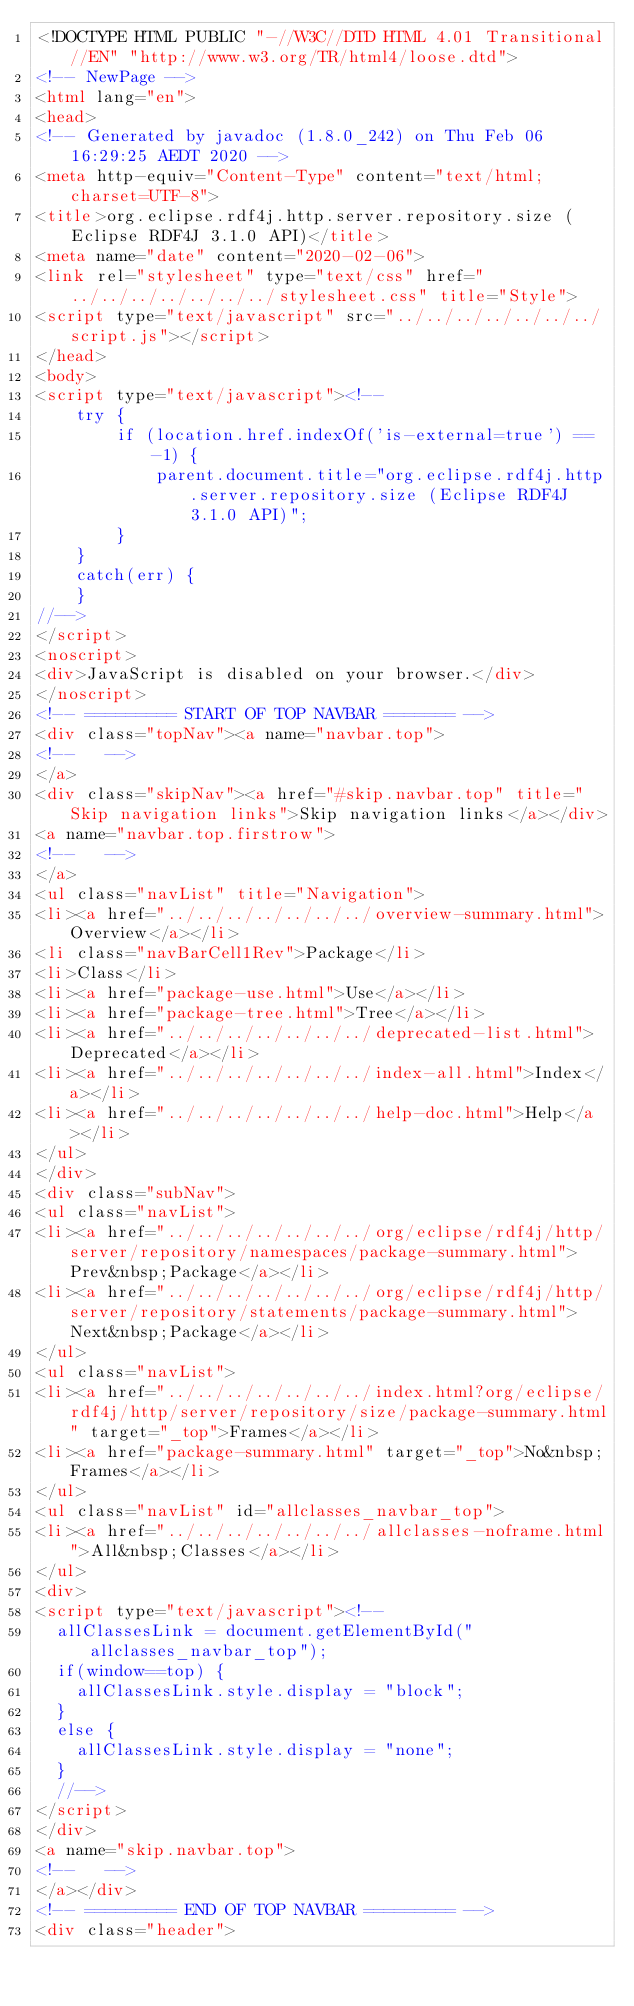<code> <loc_0><loc_0><loc_500><loc_500><_HTML_><!DOCTYPE HTML PUBLIC "-//W3C//DTD HTML 4.01 Transitional//EN" "http://www.w3.org/TR/html4/loose.dtd">
<!-- NewPage -->
<html lang="en">
<head>
<!-- Generated by javadoc (1.8.0_242) on Thu Feb 06 16:29:25 AEDT 2020 -->
<meta http-equiv="Content-Type" content="text/html; charset=UTF-8">
<title>org.eclipse.rdf4j.http.server.repository.size (Eclipse RDF4J 3.1.0 API)</title>
<meta name="date" content="2020-02-06">
<link rel="stylesheet" type="text/css" href="../../../../../../../stylesheet.css" title="Style">
<script type="text/javascript" src="../../../../../../../script.js"></script>
</head>
<body>
<script type="text/javascript"><!--
    try {
        if (location.href.indexOf('is-external=true') == -1) {
            parent.document.title="org.eclipse.rdf4j.http.server.repository.size (Eclipse RDF4J 3.1.0 API)";
        }
    }
    catch(err) {
    }
//-->
</script>
<noscript>
<div>JavaScript is disabled on your browser.</div>
</noscript>
<!-- ========= START OF TOP NAVBAR ======= -->
<div class="topNav"><a name="navbar.top">
<!--   -->
</a>
<div class="skipNav"><a href="#skip.navbar.top" title="Skip navigation links">Skip navigation links</a></div>
<a name="navbar.top.firstrow">
<!--   -->
</a>
<ul class="navList" title="Navigation">
<li><a href="../../../../../../../overview-summary.html">Overview</a></li>
<li class="navBarCell1Rev">Package</li>
<li>Class</li>
<li><a href="package-use.html">Use</a></li>
<li><a href="package-tree.html">Tree</a></li>
<li><a href="../../../../../../../deprecated-list.html">Deprecated</a></li>
<li><a href="../../../../../../../index-all.html">Index</a></li>
<li><a href="../../../../../../../help-doc.html">Help</a></li>
</ul>
</div>
<div class="subNav">
<ul class="navList">
<li><a href="../../../../../../../org/eclipse/rdf4j/http/server/repository/namespaces/package-summary.html">Prev&nbsp;Package</a></li>
<li><a href="../../../../../../../org/eclipse/rdf4j/http/server/repository/statements/package-summary.html">Next&nbsp;Package</a></li>
</ul>
<ul class="navList">
<li><a href="../../../../../../../index.html?org/eclipse/rdf4j/http/server/repository/size/package-summary.html" target="_top">Frames</a></li>
<li><a href="package-summary.html" target="_top">No&nbsp;Frames</a></li>
</ul>
<ul class="navList" id="allclasses_navbar_top">
<li><a href="../../../../../../../allclasses-noframe.html">All&nbsp;Classes</a></li>
</ul>
<div>
<script type="text/javascript"><!--
  allClassesLink = document.getElementById("allclasses_navbar_top");
  if(window==top) {
    allClassesLink.style.display = "block";
  }
  else {
    allClassesLink.style.display = "none";
  }
  //-->
</script>
</div>
<a name="skip.navbar.top">
<!--   -->
</a></div>
<!-- ========= END OF TOP NAVBAR ========= -->
<div class="header"></code> 